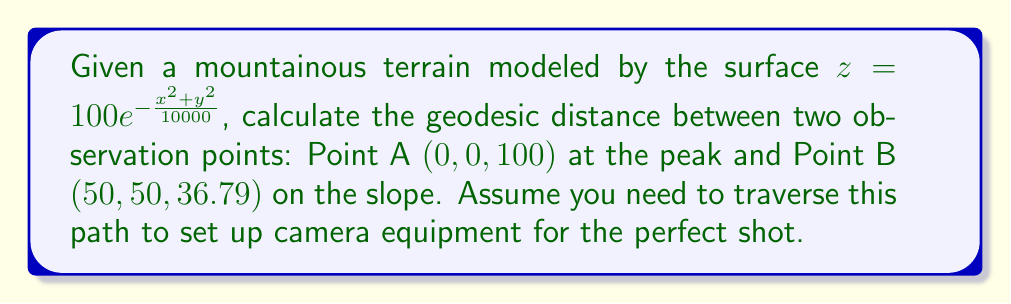Could you help me with this problem? To solve this problem, we need to follow these steps:

1) The geodesic distance on a non-Euclidean surface is given by the integral:

   $$d = \int_0^1 \sqrt{g_{ij}\frac{dx^i}{dt}\frac{dx^j}{dt}}dt$$

   where $g_{ij}$ is the metric tensor of the surface.

2) For a surface $z = f(x,y)$, the metric tensor is:

   $$g_{ij} = \begin{pmatrix}
   1+(\frac{\partial f}{\partial x})^2 & \frac{\partial f}{\partial x}\frac{\partial f}{\partial y} \\
   \frac{\partial f}{\partial x}\frac{\partial f}{\partial y} & 1+(\frac{\partial f}{\partial y})^2
   \end{pmatrix}$$

3) Calculate the partial derivatives:
   
   $$\frac{\partial f}{\partial x} = -\frac{x}{50}e^{-\frac{x^2+y^2}{10000}}$$
   $$\frac{\partial f}{\partial y} = -\frac{y}{50}e^{-\frac{x^2+y^2}{10000}}$$

4) Substitute these into the metric tensor:

   $$g_{ij} = \begin{pmatrix}
   1+\frac{x^2}{2500}e^{-\frac{x^2+y^2}{5000}} & \frac{xy}{2500}e^{-\frac{x^2+y^2}{5000}} \\
   \frac{xy}{2500}e^{-\frac{x^2+y^2}{5000}} & 1+\frac{y^2}{2500}e^{-\frac{x^2+y^2}{5000}}
   \end{pmatrix}$$

5) Assume a straight line path between the points:
   
   $$x(t) = 50t, y(t) = 50t, 0 \leq t \leq 1$$

6) Substitute into the geodesic equation:

   $$d = \int_0^1 \sqrt{(1+\frac{2500t^2}{2500}e^{-\frac{5000t^2}{5000}})(50^2) + 2(\frac{2500t^2}{2500}e^{-\frac{5000t^2}{5000}})(50^2) + (1+\frac{2500t^2}{2500}e^{-\frac{5000t^2}{5000}})(50^2)}dt$$

7) Simplify:

   $$d = 50\sqrt{2}\int_0^1 \sqrt{1+t^2e^{-t^2}}dt$$

8) This integral doesn't have a closed-form solution, so we need to use numerical integration methods to approximate it.
Answer: The geodesic distance between Point A and Point B is approximately 74.54 meters, calculated using numerical integration methods. 